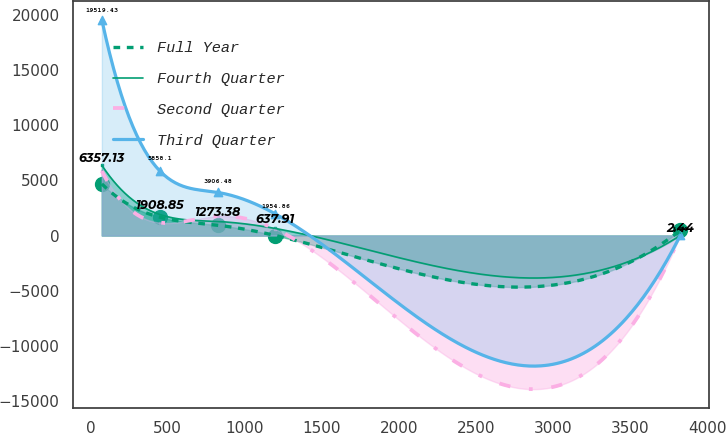<chart> <loc_0><loc_0><loc_500><loc_500><line_chart><ecel><fcel>Full Year<fcel>Fourth Quarter<fcel>Second Quarter<fcel>Third Quarter<nl><fcel>74.21<fcel>4672.03<fcel>6357.13<fcel>5830.11<fcel>19519.4<nl><fcel>449.38<fcel>1661.99<fcel>1908.85<fcel>1166.75<fcel>5858.1<nl><fcel>824.55<fcel>935.74<fcel>1273.38<fcel>1749.67<fcel>3906.48<nl><fcel>1199.72<fcel>1.66<fcel>637.91<fcel>583.83<fcel>1954.86<nl><fcel>3825.9<fcel>468.7<fcel>2.44<fcel>0.91<fcel>3.24<nl></chart> 